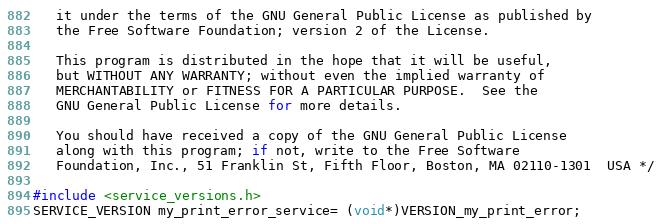<code> <loc_0><loc_0><loc_500><loc_500><_C_>   it under the terms of the GNU General Public License as published by
   the Free Software Foundation; version 2 of the License.

   This program is distributed in the hope that it will be useful,
   but WITHOUT ANY WARRANTY; without even the implied warranty of
   MERCHANTABILITY or FITNESS FOR A PARTICULAR PURPOSE.  See the
   GNU General Public License for more details.

   You should have received a copy of the GNU General Public License
   along with this program; if not, write to the Free Software
   Foundation, Inc., 51 Franklin St, Fifth Floor, Boston, MA 02110-1301  USA */

#include <service_versions.h>
SERVICE_VERSION my_print_error_service= (void*)VERSION_my_print_error;
</code> 